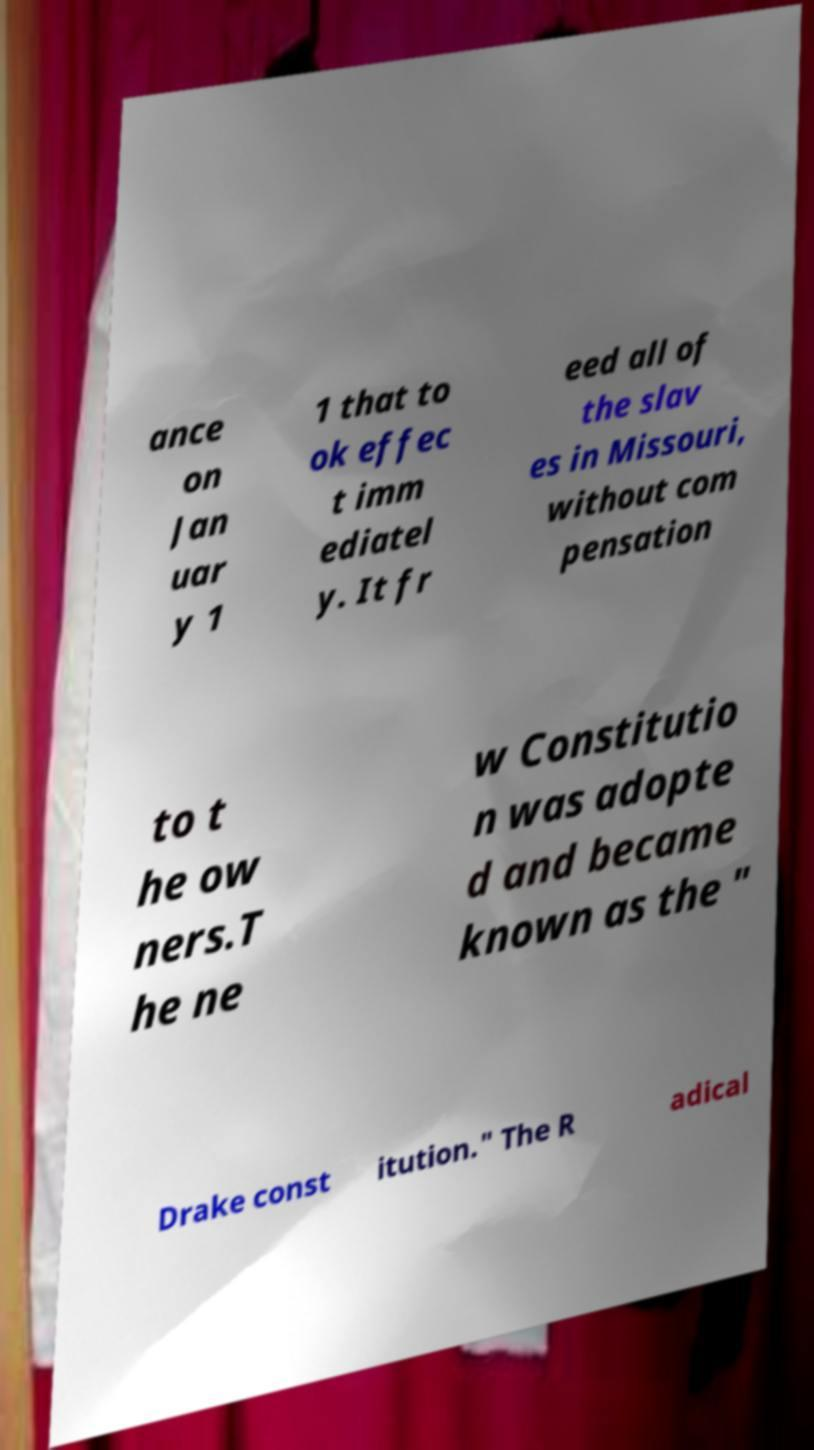Please read and relay the text visible in this image. What does it say? ance on Jan uar y 1 1 that to ok effec t imm ediatel y. It fr eed all of the slav es in Missouri, without com pensation to t he ow ners.T he ne w Constitutio n was adopte d and became known as the " Drake const itution." The R adical 